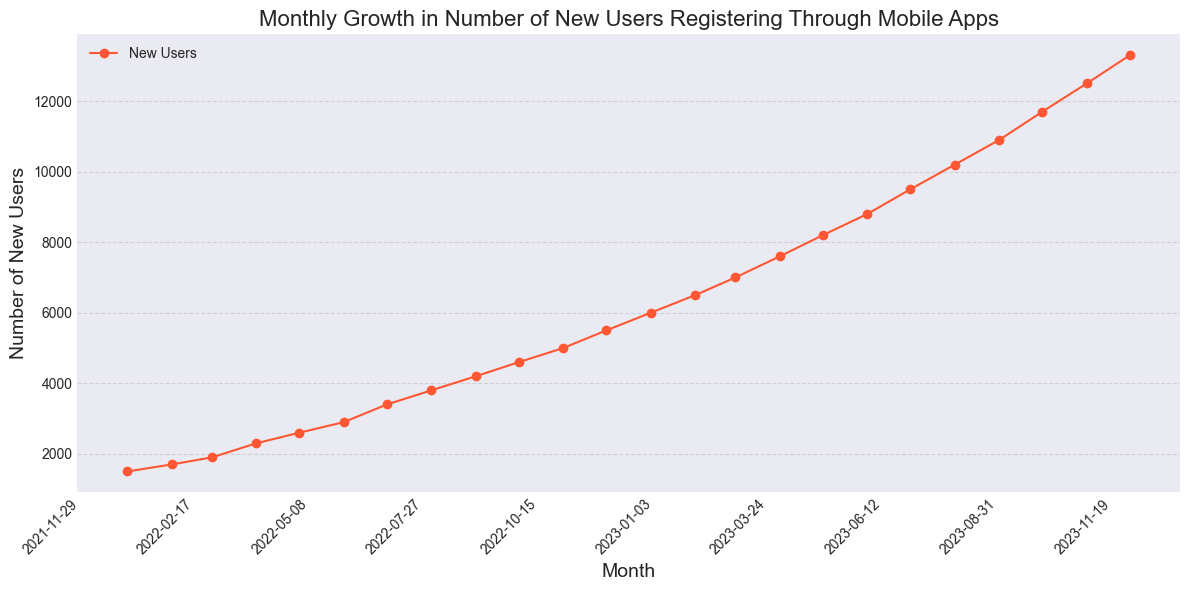What is the number of new users in December 2023? Look at the figure's data point corresponding to December 2023 on the x-axis and read the y-axis value. The line indicates 13300 new users for this month.
Answer: 13300 Compare the number of new users in January 2022 and January 2023. Which month had more, and by how much? Observe the data points for January 2022 and January 2023. January 2022 had 1500 new users and January 2023 had 6000 new users. The difference is 6000 - 1500 = 4500 new users.
Answer: January 2023 by 4500 What is the visual trend of new user registration over the two-year period? Visually assess the line plot from January 2022 to December 2023. The plot consistently rises, indicating a steady increase in new user registrations over the months.
Answer: Steady increase What is the average number of new users per month in 2022? Sum the number of new users for each month in 2022 and divide by 12. (1500 + 1700 + 1900 + 2300 + 2600 + 2900 + 3400 + 3800 + 4200 + 4600 + 5000 + 5500) / 12 = 3425
Answer: 3425 During which month in 2023 did the number of new users first exceed 10,000? Look for the point where the y-axis first shows values above 10,000 in 2023. This happens in August 2023, with 10200 new users.
Answer: August 2023 What is the total number of new users registered from January 2023 to December 2023? Sum the new users registered each month in 2023. 6000 + 6500 + 7000 + 7600 + 8200 + 8800 + 9500 + 10200 + 10900 + 11700 + 12500 + 13300 = 112200
Answer: 112200 What is the month-on-month growth rate between November 2023 and December 2023? Calculate the difference between new users in November 2023 and December 2023, then divide by the number of new users in November 2023. ((13300 - 12500) / 12500) * 100 = 6.4%
Answer: 6.4% Which month in 2022 saw the highest month-on-month increase in new users? By how much did it increase? Examine the differences between consecutive months in 2022. April 2022 saw the highest increase, from 1900 in March to 2300. The increase is 2300 - 1900 = 400.
Answer: April 2022, 400 